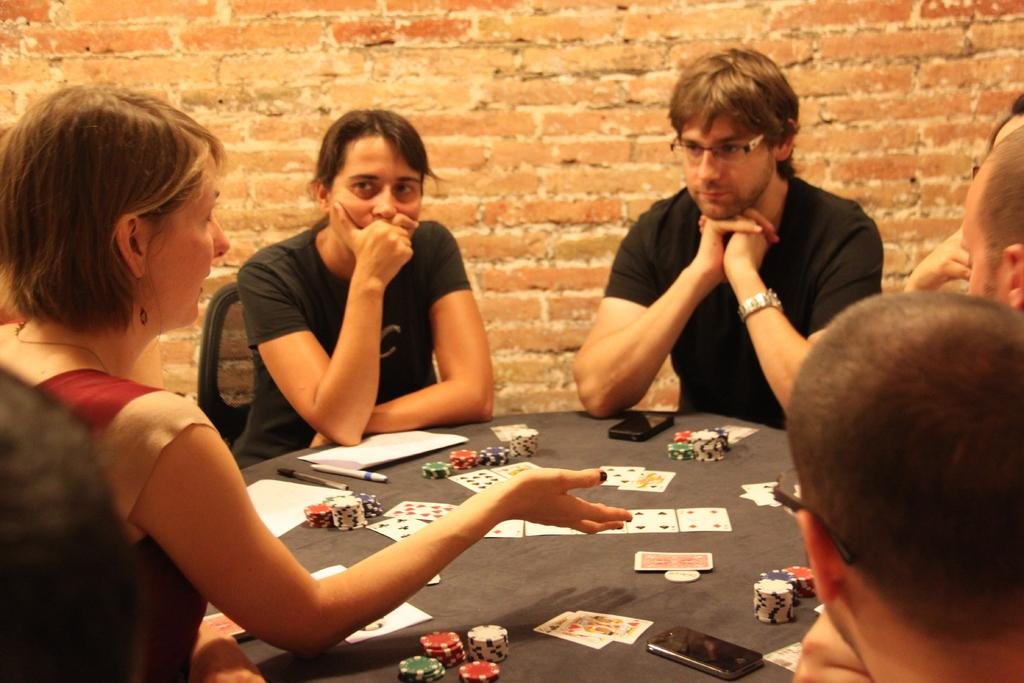What are the people in the image doing? The people in the image are playing poker. How are they positioned in the image? They are sitting around a table. Can you describe the composition of the group? There are two women and three men in the group. What is one of the women doing in the image? One woman is explaining something to the others. What type of road can be seen in the image? There is no road present in the image. The focus is on the people playing poker around a table. 